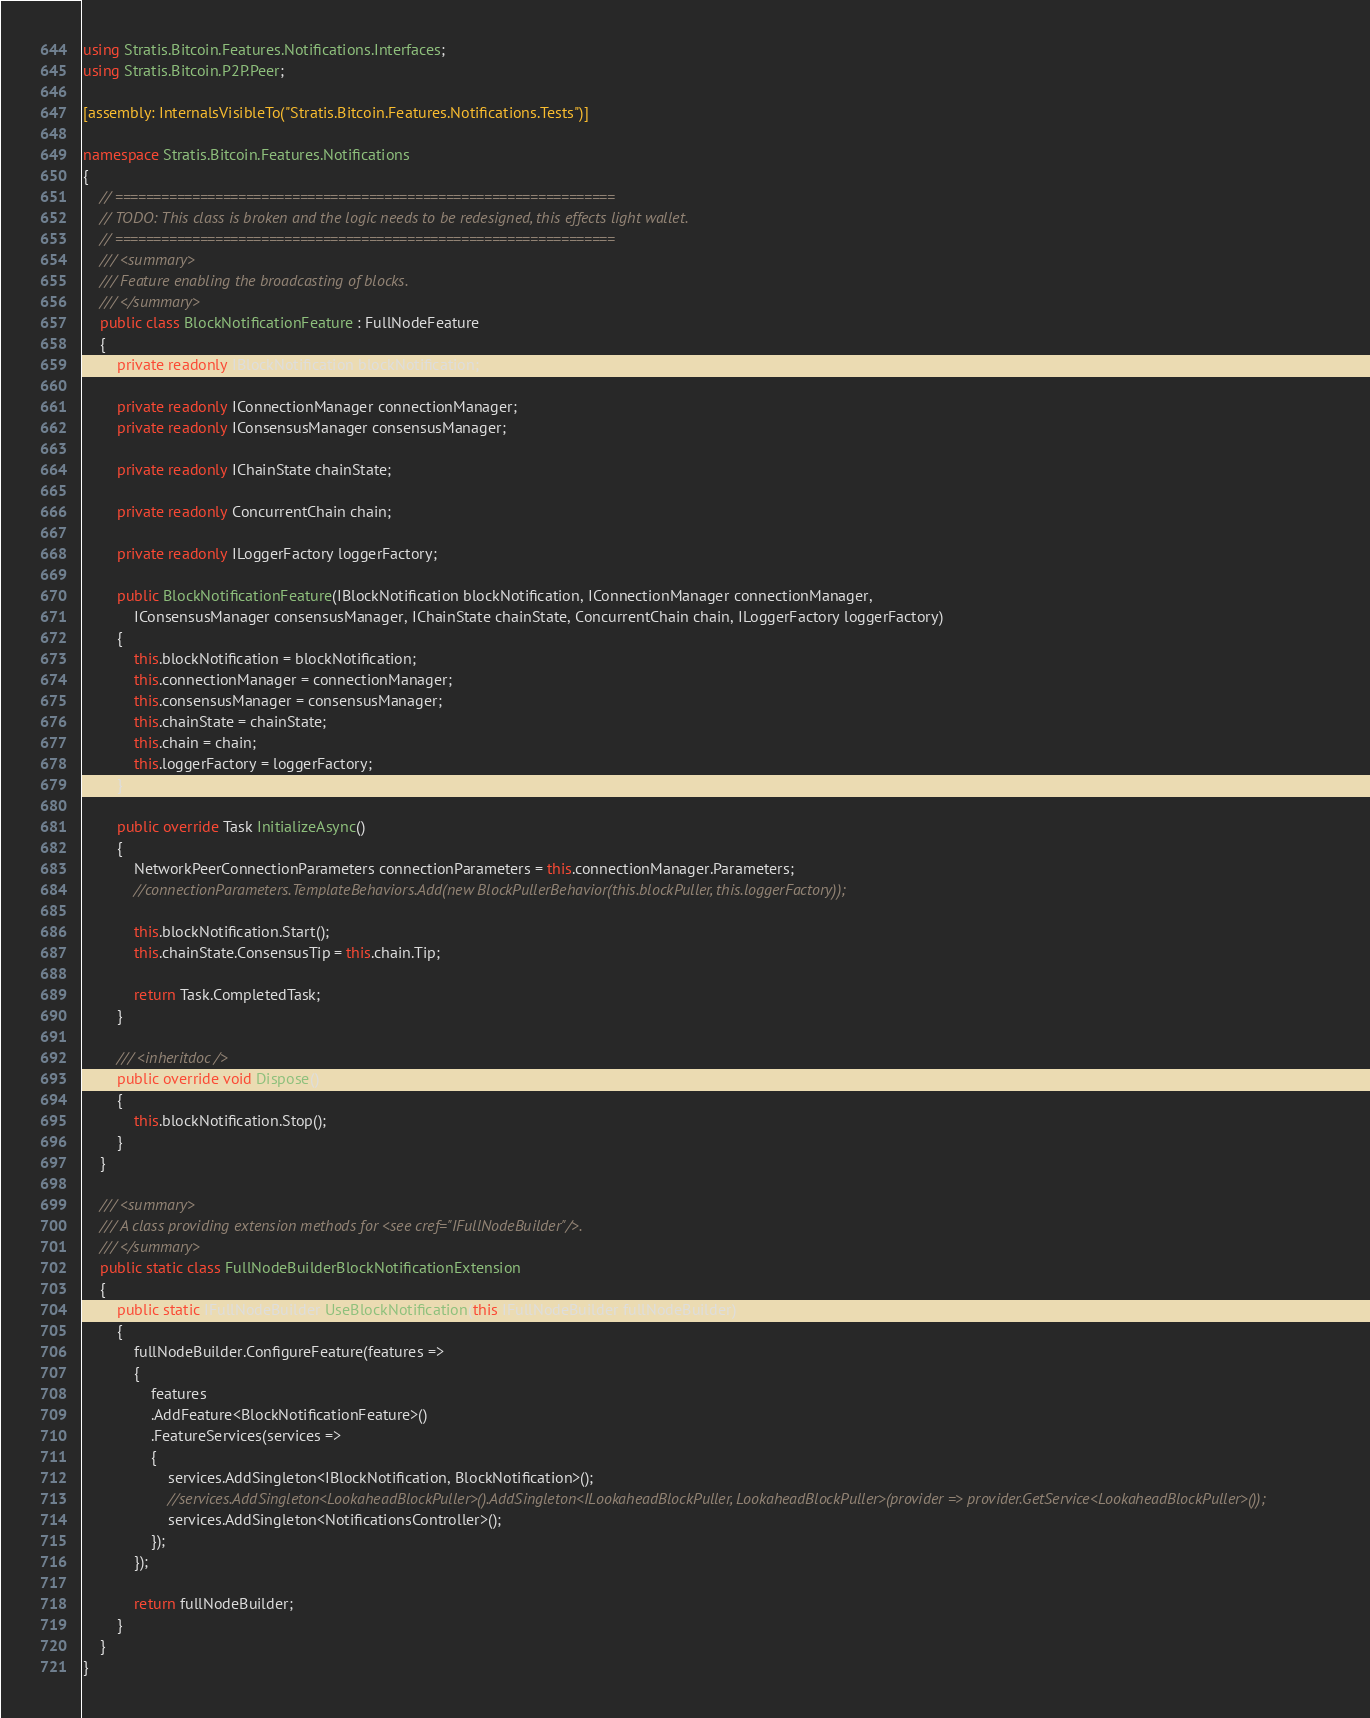<code> <loc_0><loc_0><loc_500><loc_500><_C#_>using Stratis.Bitcoin.Features.Notifications.Interfaces;
using Stratis.Bitcoin.P2P.Peer;

[assembly: InternalsVisibleTo("Stratis.Bitcoin.Features.Notifications.Tests")]

namespace Stratis.Bitcoin.Features.Notifications
{
    // =================================================================
    // TODO: This class is broken and the logic needs to be redesigned, this effects light wallet.
    // =================================================================
    /// <summary>
    /// Feature enabling the broadcasting of blocks.
    /// </summary>
    public class BlockNotificationFeature : FullNodeFeature
    {
        private readonly IBlockNotification blockNotification;

        private readonly IConnectionManager connectionManager;
        private readonly IConsensusManager consensusManager;

        private readonly IChainState chainState;

        private readonly ConcurrentChain chain;

        private readonly ILoggerFactory loggerFactory;

        public BlockNotificationFeature(IBlockNotification blockNotification, IConnectionManager connectionManager,
            IConsensusManager consensusManager, IChainState chainState, ConcurrentChain chain, ILoggerFactory loggerFactory)
        {
            this.blockNotification = blockNotification;
            this.connectionManager = connectionManager;
            this.consensusManager = consensusManager;
            this.chainState = chainState;
            this.chain = chain;
            this.loggerFactory = loggerFactory;
        }

        public override Task InitializeAsync()
        {
            NetworkPeerConnectionParameters connectionParameters = this.connectionManager.Parameters;
            //connectionParameters.TemplateBehaviors.Add(new BlockPullerBehavior(this.blockPuller, this.loggerFactory));

            this.blockNotification.Start();
            this.chainState.ConsensusTip = this.chain.Tip;

            return Task.CompletedTask;
        }

        /// <inheritdoc />
        public override void Dispose()
        {
            this.blockNotification.Stop();
        }
    }

    /// <summary>
    /// A class providing extension methods for <see cref="IFullNodeBuilder"/>.
    /// </summary>
    public static class FullNodeBuilderBlockNotificationExtension
    {
        public static IFullNodeBuilder UseBlockNotification(this IFullNodeBuilder fullNodeBuilder)
        {
            fullNodeBuilder.ConfigureFeature(features =>
            {
                features
                .AddFeature<BlockNotificationFeature>()
                .FeatureServices(services =>
                {
                    services.AddSingleton<IBlockNotification, BlockNotification>();
                    //services.AddSingleton<LookaheadBlockPuller>().AddSingleton<ILookaheadBlockPuller, LookaheadBlockPuller>(provider => provider.GetService<LookaheadBlockPuller>());
                    services.AddSingleton<NotificationsController>();
                });
            });

            return fullNodeBuilder;
        }
    }
}
</code> 